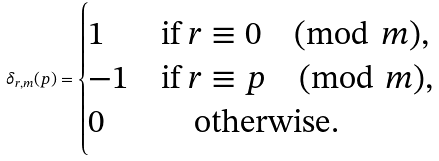Convert formula to latex. <formula><loc_0><loc_0><loc_500><loc_500>\delta _ { r , m } ( p ) = \begin{cases} 1 & \text {if } r \equiv 0 \pmod { m } , \\ - 1 & \text {if } r \equiv p \pmod { m } , \\ 0 & \quad \text {otherwise} . \end{cases}</formula> 